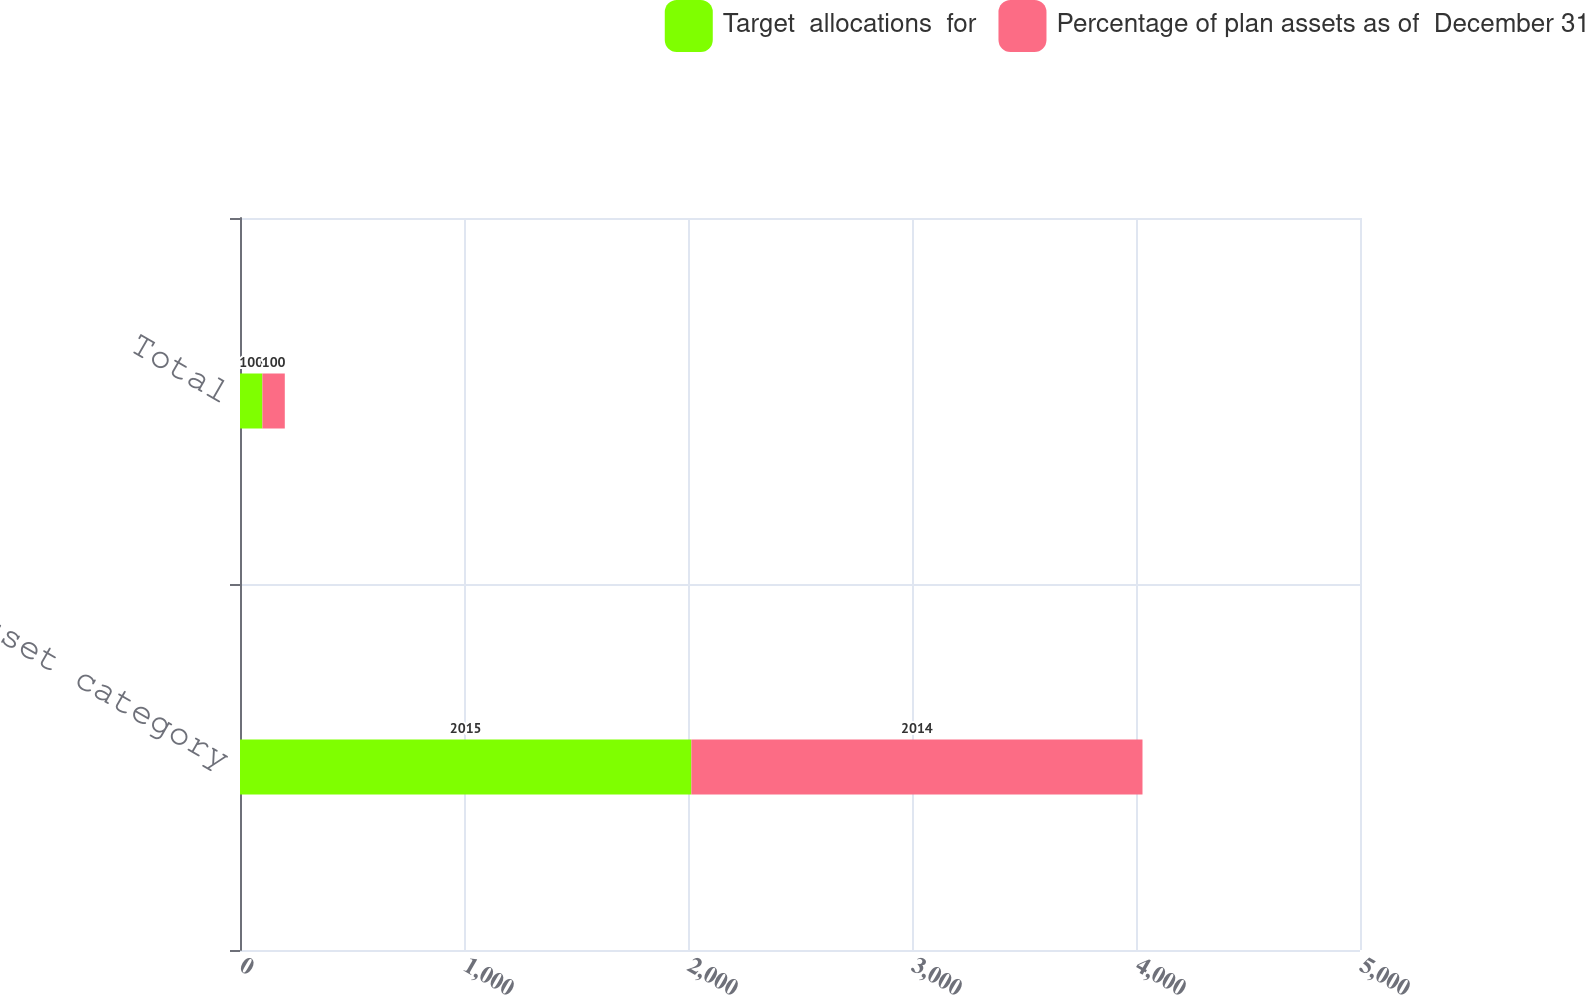<chart> <loc_0><loc_0><loc_500><loc_500><stacked_bar_chart><ecel><fcel>Asset category<fcel>Total<nl><fcel>Target  allocations  for<fcel>2015<fcel>100<nl><fcel>Percentage of plan assets as of  December 31<fcel>2014<fcel>100<nl></chart> 